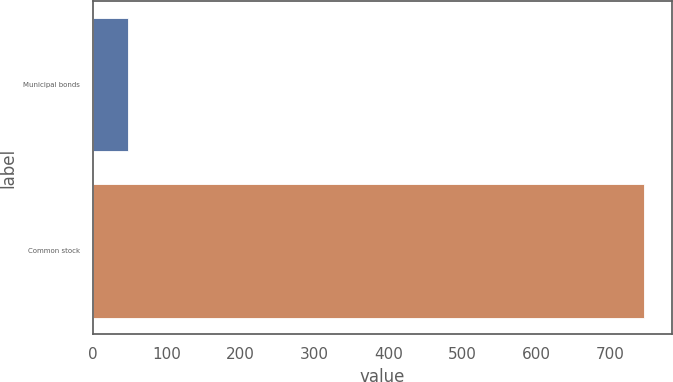Convert chart. <chart><loc_0><loc_0><loc_500><loc_500><bar_chart><fcel>Municipal bonds<fcel>Common stock<nl><fcel>47<fcel>747<nl></chart> 